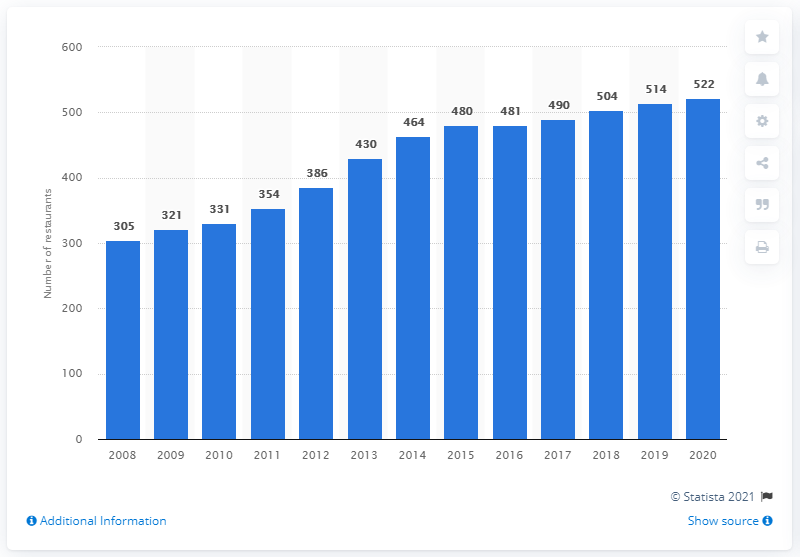Give some essential details in this illustration. At the end of the 2020 fiscal year, there were 522 LongHorn Steakhouse restaurants located in North America. 